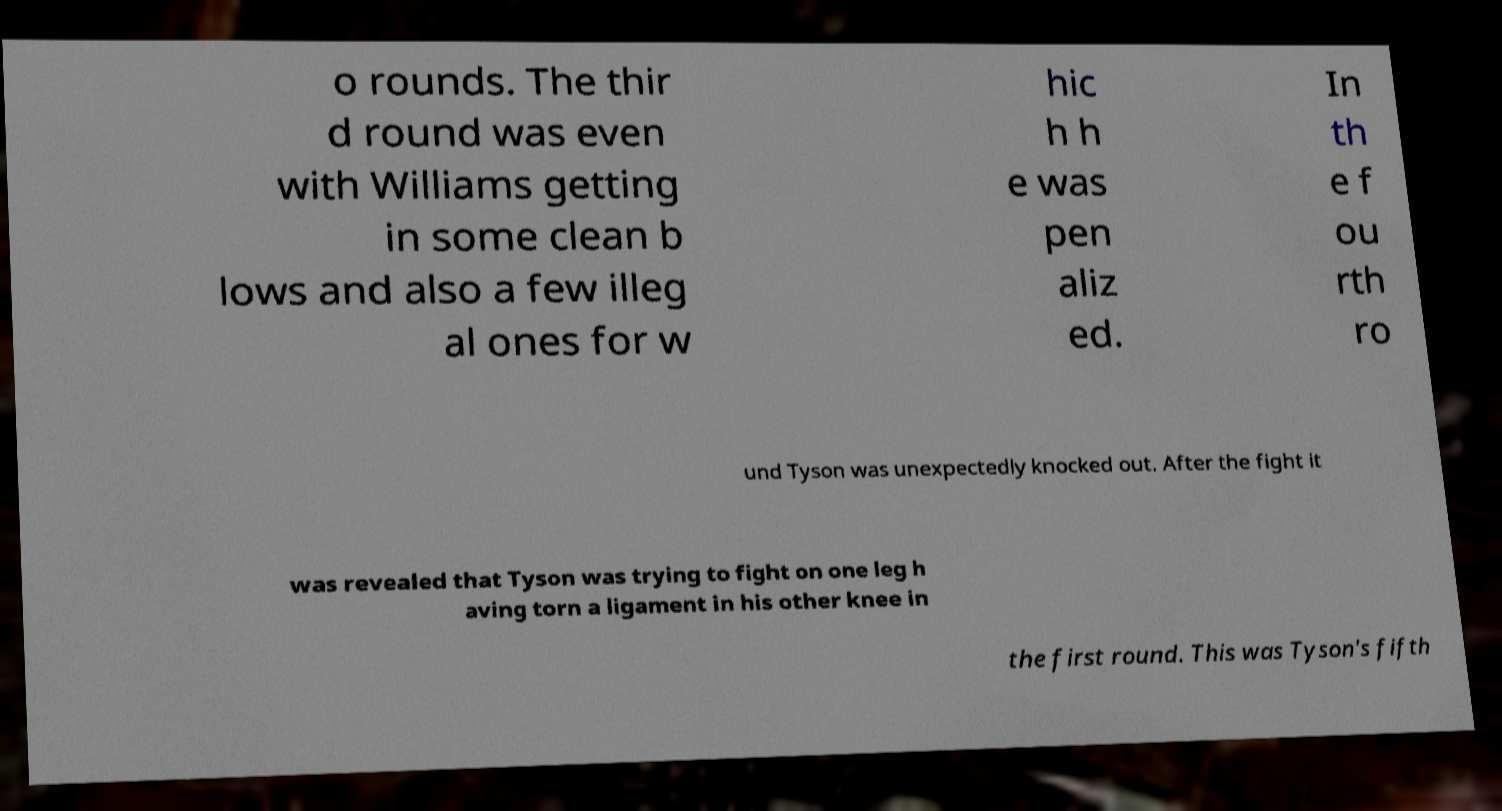There's text embedded in this image that I need extracted. Can you transcribe it verbatim? o rounds. The thir d round was even with Williams getting in some clean b lows and also a few illeg al ones for w hic h h e was pen aliz ed. In th e f ou rth ro und Tyson was unexpectedly knocked out. After the fight it was revealed that Tyson was trying to fight on one leg h aving torn a ligament in his other knee in the first round. This was Tyson's fifth 